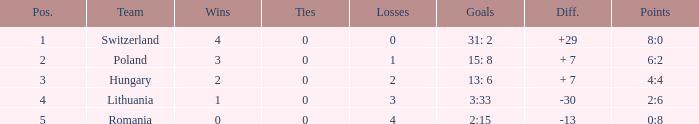What is the maximum number of wins with less than 4 losses and greater than 0 stalemates? None. 